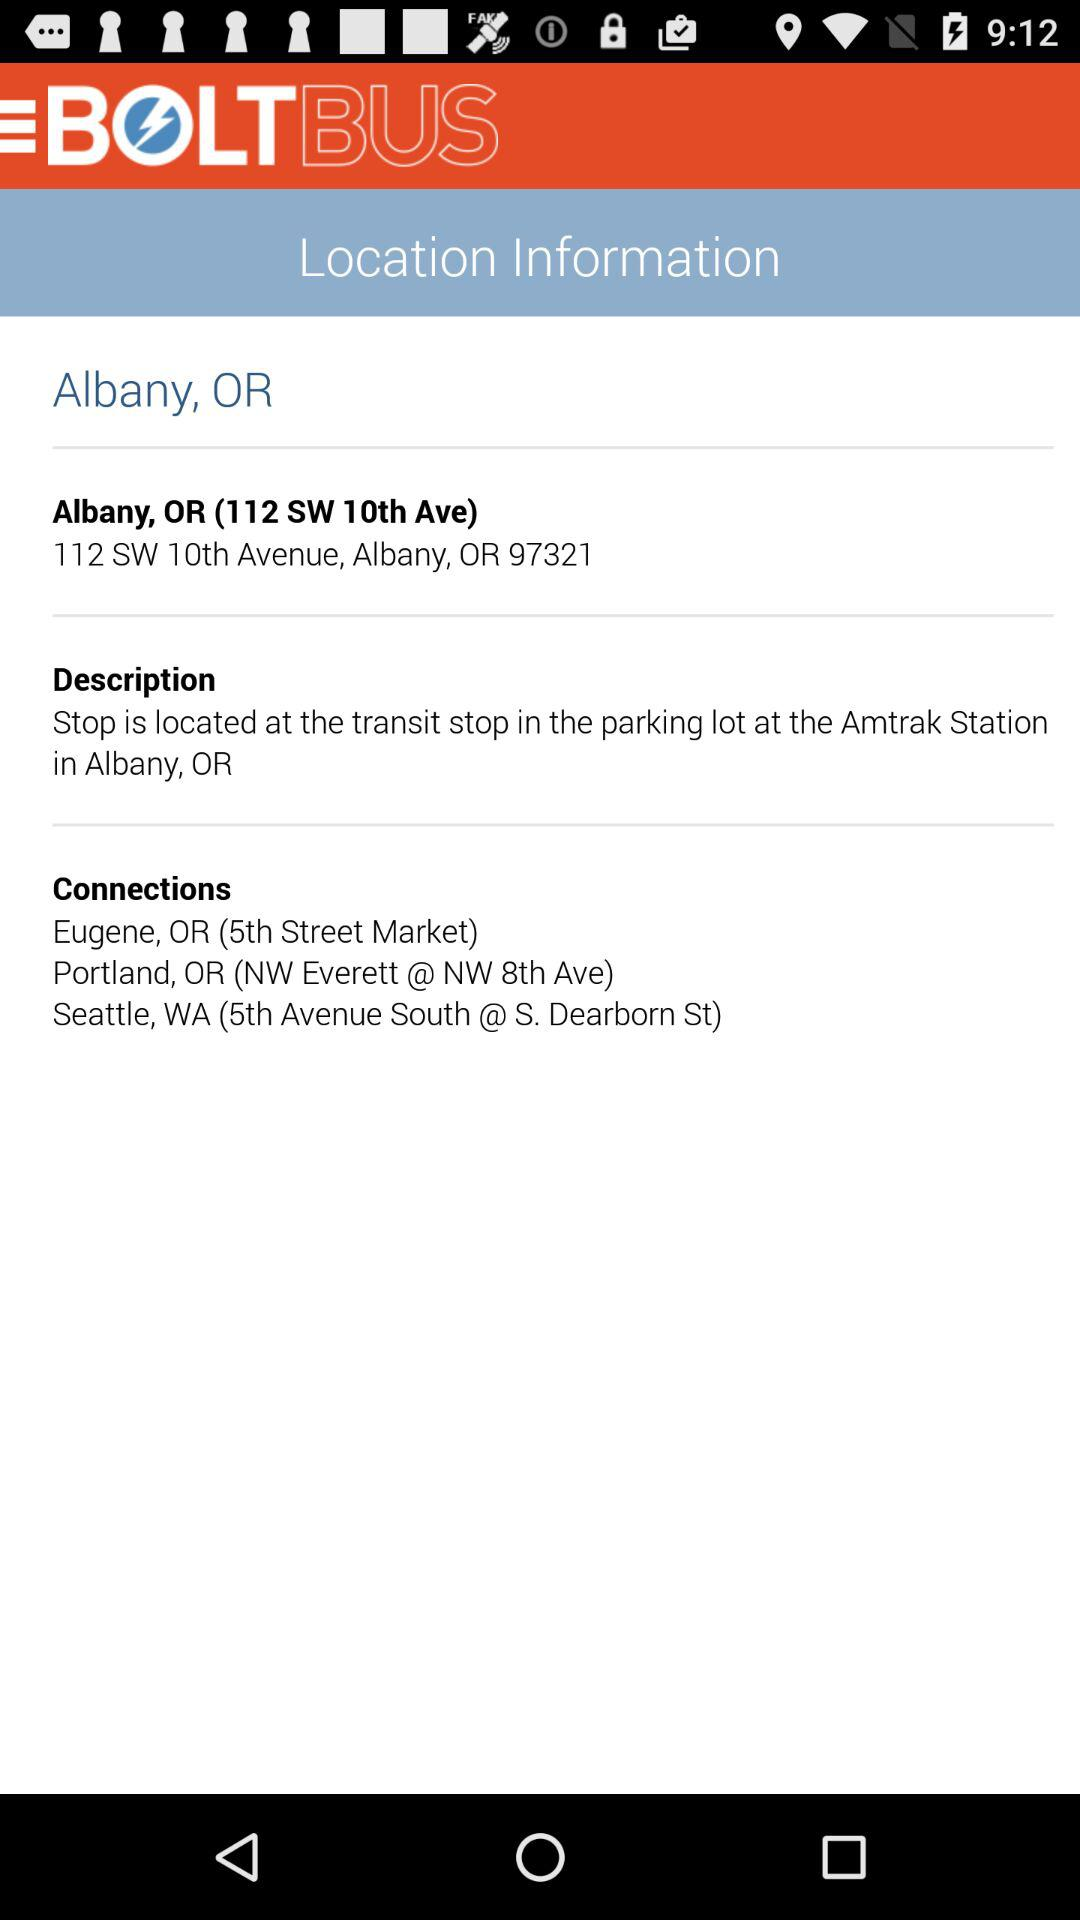What is the address? The address is 112 SW 10th Avenue, Albany, OR 97321. 